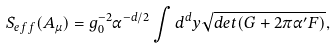Convert formula to latex. <formula><loc_0><loc_0><loc_500><loc_500>S _ { e f f } ( A _ { \mu } ) = g _ { 0 } ^ { - 2 } \alpha ^ { - d / 2 } \int d ^ { d } y \sqrt { d e t ( G + 2 \pi \alpha ^ { \prime } F ) } ,</formula> 